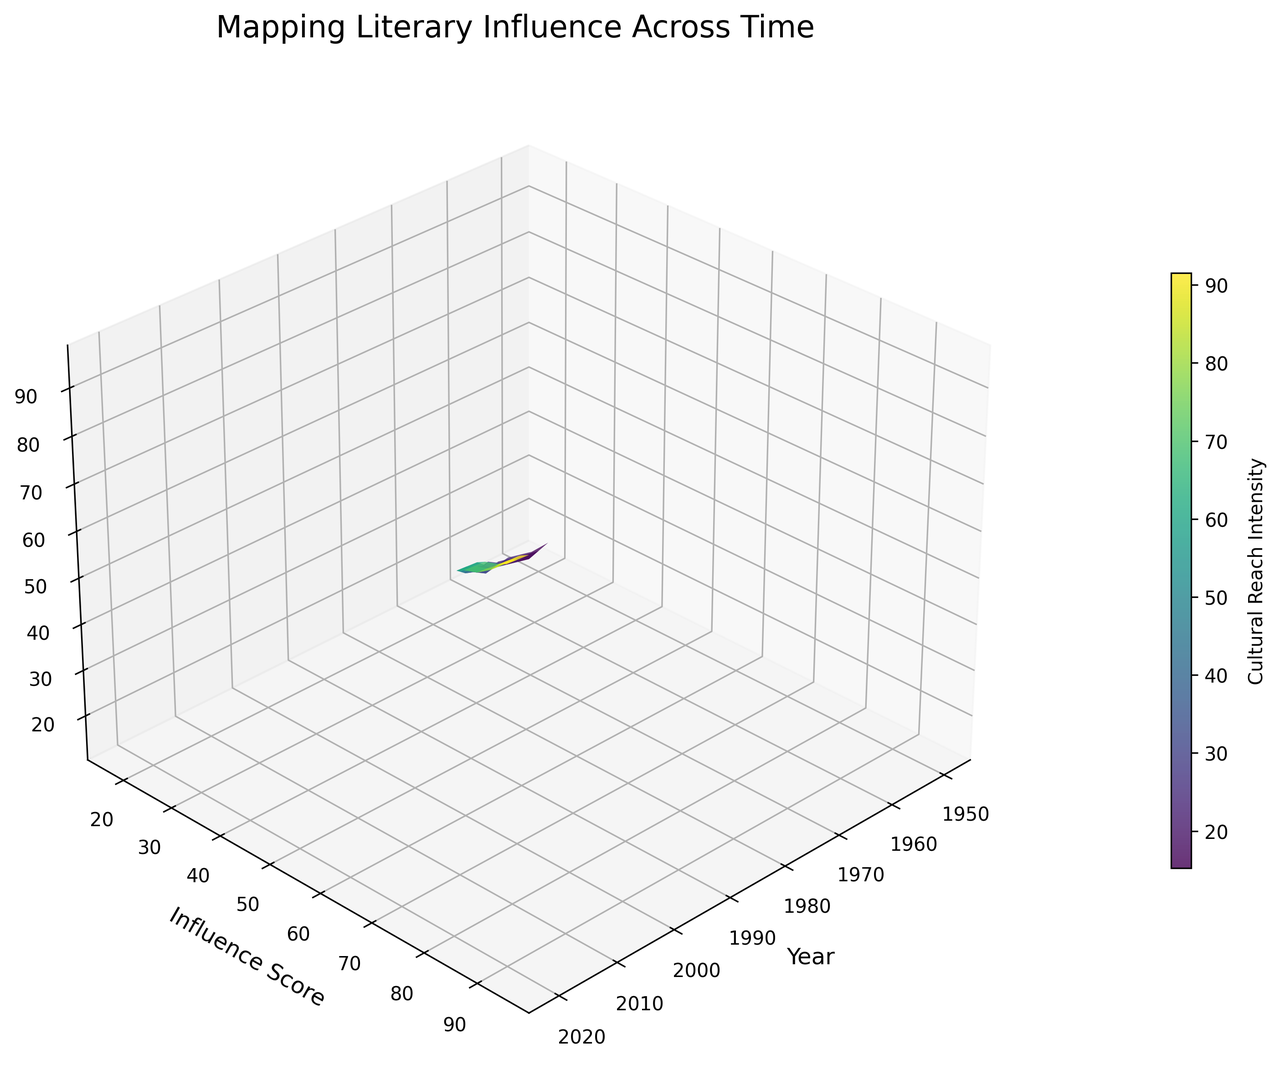What is the trend of the Influence Score from 1950 to 2020 as shown in the figure? The figure shows that the Influence Score trends upwards from 1950 to 2020. This indicates that contemporary fiction has steadily drawn more influence from classic literary works over time.
Answer: Upward trend Between which years does the Cultural Reach show the most significant increase? By examining the figure, it is clear that the Cultural Reach shows the most significant increase between 2000 and 2020. The steepness of the surface plot in this period indicates a rapid rise in Cultural Reach.
Answer: 2000 to 2020 Which year shows the highest Influence Score and Cultural Reach collectively? The highest points on the Z-axis towards the end of the timeline indicate the year 2020 has the highest combined Influence Score and Cultural Reach.
Answer: 2020 At what approximate Influence Score does the Cultural Reach reach 70? By tracing the figure where the Z-axis value for Cultural Reach is around 70, the corresponding Influence Score is approximately 68.
Answer: Approximately 68 Compare the Cultural Reach between 1970 and 1980. Which year has a higher value? When comparing the heights on the Z-axis for 1970 and 1980, 1980 shows a higher value of Cultural Reach.
Answer: 1980 What is the average Cultural Reach between 2000 and 2020? To find the average Cultural Reach between 2000 and 2020, add the Cultural Reach values for those years (65 + 72 + 80 + 88 + 95) and divide by the number of data points (5), resulting in an average of 80.
Answer: 80 How does the color gradient change as Cultural Reach increases? The color of the surface plot changes from a dark shade to a lighter shade as the Cultural Reach increases, indicating higher intensity.
Answer: Dark to light What Influence Score does the year 1990 have, and how does it compare to the Influence Score of 1985? By examining the surface plot, the Influence Score for 1990 appears to be slightly higher than for 1985.
Answer: Higher What is the median Influence Score between 1980 and 2005? To find the median Influence Score, list the scores between 1980 and 2005 (40, 45, 50, 55, 62, 70) and find the median value, which is 55.
Answer: 55 